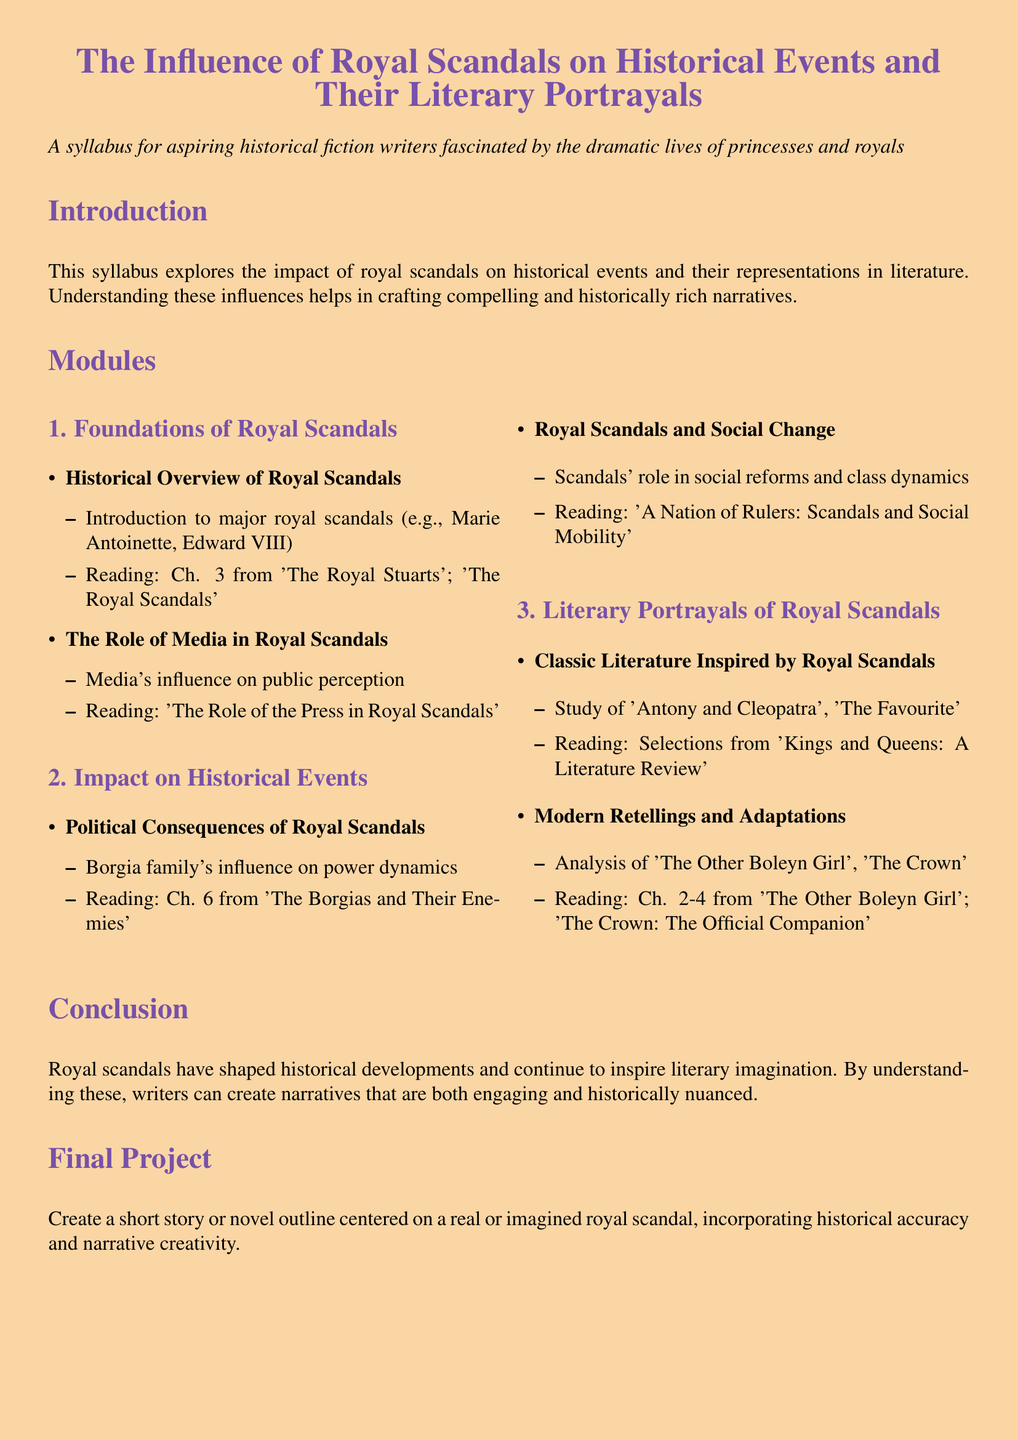What is the title of the syllabus? The title is presented at the top of the document and serves as the main header.
Answer: The Influence of Royal Scandals on Historical Events and Their Literary Portrayals What is the primary focus of this syllabus? The primary focus is outlined in the introduction, highlighting the impact of royal scandals and their representation in literature.
Answer: The impact of royal scandals on historical events and their representations in literature Which historical figure is mentioned as an example of a major royal scandal? The document references significant historical scandals and lists specific figures exemplifying these occurrences.
Answer: Marie Antoinette What chapter is recommended reading for understanding the political consequences of royal scandals? The syllabus specifies particular chapters from related literature that students should read, which gives context to the discussed topics.
Answer: Chapter 6 from 'The Borgias and Their Enemies' How many modules are outlined in the syllabus? The number of modules is explicitly stated under the section detailing the curriculum structure.
Answer: 3 Which literary works are analyzed in the section on classic literature? Specific works mentioned indicate their relevance and influence within the context of royal scandals in literature.
Answer: Antony and Cleopatra, The Favourite What is the final project requirement? The conclusion section outlines the task for the students, summarizing what is expected from their final work.
Answer: Create a short story or novel outline centered on a real or imagined royal scandal What type of media influence is discussed in the syllabus? The role of media is highlighted in the context of public perception, showing its importance in the era of royal scandals.
Answer: Media's influence on public perception Which royal family is mentioned concerning the political dynamics in the syllabus? The syllabus includes information about specific families that were influential in historical power struggles, noting their key role.
Answer: Borgia family 